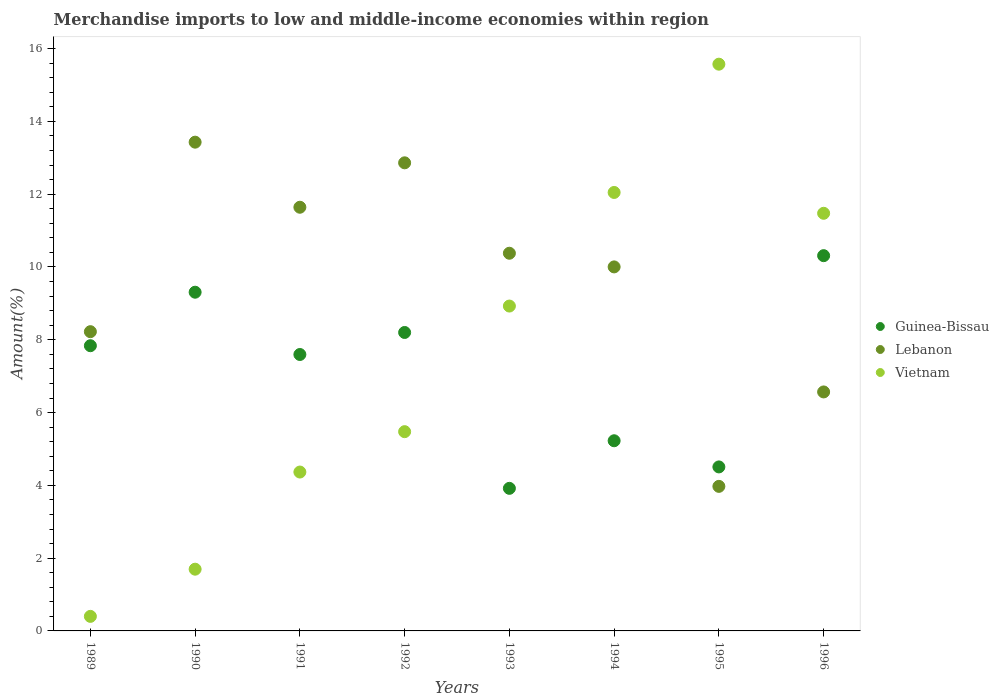Is the number of dotlines equal to the number of legend labels?
Your answer should be very brief. Yes. What is the percentage of amount earned from merchandise imports in Lebanon in 1996?
Your response must be concise. 6.57. Across all years, what is the maximum percentage of amount earned from merchandise imports in Vietnam?
Ensure brevity in your answer.  15.57. Across all years, what is the minimum percentage of amount earned from merchandise imports in Vietnam?
Provide a succinct answer. 0.4. In which year was the percentage of amount earned from merchandise imports in Lebanon minimum?
Offer a terse response. 1995. What is the total percentage of amount earned from merchandise imports in Vietnam in the graph?
Your response must be concise. 59.96. What is the difference between the percentage of amount earned from merchandise imports in Lebanon in 1989 and that in 1991?
Make the answer very short. -3.42. What is the difference between the percentage of amount earned from merchandise imports in Vietnam in 1994 and the percentage of amount earned from merchandise imports in Guinea-Bissau in 1995?
Make the answer very short. 7.54. What is the average percentage of amount earned from merchandise imports in Vietnam per year?
Make the answer very short. 7.49. In the year 1990, what is the difference between the percentage of amount earned from merchandise imports in Lebanon and percentage of amount earned from merchandise imports in Guinea-Bissau?
Ensure brevity in your answer.  4.12. In how many years, is the percentage of amount earned from merchandise imports in Guinea-Bissau greater than 4 %?
Give a very brief answer. 7. What is the ratio of the percentage of amount earned from merchandise imports in Lebanon in 1991 to that in 1996?
Your response must be concise. 1.77. Is the percentage of amount earned from merchandise imports in Guinea-Bissau in 1993 less than that in 1996?
Keep it short and to the point. Yes. What is the difference between the highest and the second highest percentage of amount earned from merchandise imports in Guinea-Bissau?
Provide a short and direct response. 1. What is the difference between the highest and the lowest percentage of amount earned from merchandise imports in Vietnam?
Ensure brevity in your answer.  15.17. In how many years, is the percentage of amount earned from merchandise imports in Vietnam greater than the average percentage of amount earned from merchandise imports in Vietnam taken over all years?
Ensure brevity in your answer.  4. Is the sum of the percentage of amount earned from merchandise imports in Vietnam in 1991 and 1996 greater than the maximum percentage of amount earned from merchandise imports in Lebanon across all years?
Keep it short and to the point. Yes. Is it the case that in every year, the sum of the percentage of amount earned from merchandise imports in Guinea-Bissau and percentage of amount earned from merchandise imports in Vietnam  is greater than the percentage of amount earned from merchandise imports in Lebanon?
Provide a short and direct response. No. Is the percentage of amount earned from merchandise imports in Guinea-Bissau strictly greater than the percentage of amount earned from merchandise imports in Lebanon over the years?
Your response must be concise. No. Is the percentage of amount earned from merchandise imports in Guinea-Bissau strictly less than the percentage of amount earned from merchandise imports in Vietnam over the years?
Provide a succinct answer. No. How many years are there in the graph?
Provide a succinct answer. 8. What is the difference between two consecutive major ticks on the Y-axis?
Offer a terse response. 2. Are the values on the major ticks of Y-axis written in scientific E-notation?
Your answer should be compact. No. Does the graph contain any zero values?
Offer a very short reply. No. How many legend labels are there?
Provide a short and direct response. 3. What is the title of the graph?
Offer a very short reply. Merchandise imports to low and middle-income economies within region. What is the label or title of the Y-axis?
Keep it short and to the point. Amount(%). What is the Amount(%) in Guinea-Bissau in 1989?
Provide a succinct answer. 7.84. What is the Amount(%) in Lebanon in 1989?
Your response must be concise. 8.22. What is the Amount(%) in Vietnam in 1989?
Make the answer very short. 0.4. What is the Amount(%) of Guinea-Bissau in 1990?
Make the answer very short. 9.31. What is the Amount(%) in Lebanon in 1990?
Make the answer very short. 13.43. What is the Amount(%) in Vietnam in 1990?
Make the answer very short. 1.7. What is the Amount(%) in Guinea-Bissau in 1991?
Provide a succinct answer. 7.6. What is the Amount(%) of Lebanon in 1991?
Provide a short and direct response. 11.64. What is the Amount(%) of Vietnam in 1991?
Keep it short and to the point. 4.37. What is the Amount(%) of Guinea-Bissau in 1992?
Provide a short and direct response. 8.2. What is the Amount(%) in Lebanon in 1992?
Offer a terse response. 12.86. What is the Amount(%) in Vietnam in 1992?
Provide a short and direct response. 5.48. What is the Amount(%) of Guinea-Bissau in 1993?
Ensure brevity in your answer.  3.92. What is the Amount(%) in Lebanon in 1993?
Keep it short and to the point. 10.38. What is the Amount(%) of Vietnam in 1993?
Your answer should be very brief. 8.93. What is the Amount(%) in Guinea-Bissau in 1994?
Keep it short and to the point. 5.23. What is the Amount(%) of Lebanon in 1994?
Offer a very short reply. 10. What is the Amount(%) of Vietnam in 1994?
Your response must be concise. 12.05. What is the Amount(%) of Guinea-Bissau in 1995?
Keep it short and to the point. 4.51. What is the Amount(%) of Lebanon in 1995?
Ensure brevity in your answer.  3.97. What is the Amount(%) in Vietnam in 1995?
Your answer should be compact. 15.57. What is the Amount(%) of Guinea-Bissau in 1996?
Offer a terse response. 10.31. What is the Amount(%) of Lebanon in 1996?
Your answer should be very brief. 6.57. What is the Amount(%) in Vietnam in 1996?
Provide a succinct answer. 11.48. Across all years, what is the maximum Amount(%) in Guinea-Bissau?
Make the answer very short. 10.31. Across all years, what is the maximum Amount(%) in Lebanon?
Give a very brief answer. 13.43. Across all years, what is the maximum Amount(%) of Vietnam?
Make the answer very short. 15.57. Across all years, what is the minimum Amount(%) of Guinea-Bissau?
Offer a terse response. 3.92. Across all years, what is the minimum Amount(%) in Lebanon?
Provide a short and direct response. 3.97. Across all years, what is the minimum Amount(%) of Vietnam?
Your answer should be very brief. 0.4. What is the total Amount(%) of Guinea-Bissau in the graph?
Provide a succinct answer. 56.9. What is the total Amount(%) in Lebanon in the graph?
Your answer should be very brief. 77.07. What is the total Amount(%) in Vietnam in the graph?
Ensure brevity in your answer.  59.96. What is the difference between the Amount(%) in Guinea-Bissau in 1989 and that in 1990?
Give a very brief answer. -1.47. What is the difference between the Amount(%) in Lebanon in 1989 and that in 1990?
Keep it short and to the point. -5.21. What is the difference between the Amount(%) in Vietnam in 1989 and that in 1990?
Make the answer very short. -1.3. What is the difference between the Amount(%) of Guinea-Bissau in 1989 and that in 1991?
Offer a very short reply. 0.24. What is the difference between the Amount(%) of Lebanon in 1989 and that in 1991?
Your response must be concise. -3.42. What is the difference between the Amount(%) of Vietnam in 1989 and that in 1991?
Provide a short and direct response. -3.97. What is the difference between the Amount(%) of Guinea-Bissau in 1989 and that in 1992?
Make the answer very short. -0.36. What is the difference between the Amount(%) in Lebanon in 1989 and that in 1992?
Your answer should be very brief. -4.64. What is the difference between the Amount(%) of Vietnam in 1989 and that in 1992?
Keep it short and to the point. -5.08. What is the difference between the Amount(%) of Guinea-Bissau in 1989 and that in 1993?
Provide a succinct answer. 3.92. What is the difference between the Amount(%) of Lebanon in 1989 and that in 1993?
Your answer should be compact. -2.16. What is the difference between the Amount(%) in Vietnam in 1989 and that in 1993?
Your response must be concise. -8.53. What is the difference between the Amount(%) in Guinea-Bissau in 1989 and that in 1994?
Your answer should be compact. 2.61. What is the difference between the Amount(%) in Lebanon in 1989 and that in 1994?
Your response must be concise. -1.78. What is the difference between the Amount(%) of Vietnam in 1989 and that in 1994?
Keep it short and to the point. -11.65. What is the difference between the Amount(%) of Guinea-Bissau in 1989 and that in 1995?
Ensure brevity in your answer.  3.33. What is the difference between the Amount(%) of Lebanon in 1989 and that in 1995?
Provide a short and direct response. 4.25. What is the difference between the Amount(%) in Vietnam in 1989 and that in 1995?
Make the answer very short. -15.17. What is the difference between the Amount(%) of Guinea-Bissau in 1989 and that in 1996?
Make the answer very short. -2.47. What is the difference between the Amount(%) of Lebanon in 1989 and that in 1996?
Your answer should be compact. 1.66. What is the difference between the Amount(%) in Vietnam in 1989 and that in 1996?
Make the answer very short. -11.08. What is the difference between the Amount(%) in Guinea-Bissau in 1990 and that in 1991?
Ensure brevity in your answer.  1.71. What is the difference between the Amount(%) in Lebanon in 1990 and that in 1991?
Provide a short and direct response. 1.79. What is the difference between the Amount(%) in Vietnam in 1990 and that in 1991?
Offer a terse response. -2.67. What is the difference between the Amount(%) in Guinea-Bissau in 1990 and that in 1992?
Offer a very short reply. 1.11. What is the difference between the Amount(%) in Lebanon in 1990 and that in 1992?
Offer a terse response. 0.57. What is the difference between the Amount(%) of Vietnam in 1990 and that in 1992?
Keep it short and to the point. -3.78. What is the difference between the Amount(%) of Guinea-Bissau in 1990 and that in 1993?
Provide a succinct answer. 5.39. What is the difference between the Amount(%) of Lebanon in 1990 and that in 1993?
Ensure brevity in your answer.  3.05. What is the difference between the Amount(%) in Vietnam in 1990 and that in 1993?
Keep it short and to the point. -7.23. What is the difference between the Amount(%) in Guinea-Bissau in 1990 and that in 1994?
Offer a terse response. 4.08. What is the difference between the Amount(%) of Lebanon in 1990 and that in 1994?
Provide a succinct answer. 3.43. What is the difference between the Amount(%) of Vietnam in 1990 and that in 1994?
Provide a succinct answer. -10.35. What is the difference between the Amount(%) in Guinea-Bissau in 1990 and that in 1995?
Your answer should be compact. 4.8. What is the difference between the Amount(%) in Lebanon in 1990 and that in 1995?
Your answer should be compact. 9.46. What is the difference between the Amount(%) in Vietnam in 1990 and that in 1995?
Provide a succinct answer. -13.88. What is the difference between the Amount(%) in Guinea-Bissau in 1990 and that in 1996?
Your answer should be compact. -1. What is the difference between the Amount(%) of Lebanon in 1990 and that in 1996?
Give a very brief answer. 6.86. What is the difference between the Amount(%) of Vietnam in 1990 and that in 1996?
Provide a short and direct response. -9.78. What is the difference between the Amount(%) of Guinea-Bissau in 1991 and that in 1992?
Your response must be concise. -0.61. What is the difference between the Amount(%) of Lebanon in 1991 and that in 1992?
Offer a very short reply. -1.22. What is the difference between the Amount(%) in Vietnam in 1991 and that in 1992?
Provide a succinct answer. -1.11. What is the difference between the Amount(%) in Guinea-Bissau in 1991 and that in 1993?
Your answer should be compact. 3.68. What is the difference between the Amount(%) in Lebanon in 1991 and that in 1993?
Offer a very short reply. 1.26. What is the difference between the Amount(%) in Vietnam in 1991 and that in 1993?
Provide a short and direct response. -4.56. What is the difference between the Amount(%) of Guinea-Bissau in 1991 and that in 1994?
Provide a short and direct response. 2.37. What is the difference between the Amount(%) of Lebanon in 1991 and that in 1994?
Keep it short and to the point. 1.64. What is the difference between the Amount(%) of Vietnam in 1991 and that in 1994?
Provide a short and direct response. -7.68. What is the difference between the Amount(%) in Guinea-Bissau in 1991 and that in 1995?
Offer a very short reply. 3.09. What is the difference between the Amount(%) of Lebanon in 1991 and that in 1995?
Provide a succinct answer. 7.67. What is the difference between the Amount(%) of Vietnam in 1991 and that in 1995?
Provide a succinct answer. -11.21. What is the difference between the Amount(%) of Guinea-Bissau in 1991 and that in 1996?
Give a very brief answer. -2.72. What is the difference between the Amount(%) in Lebanon in 1991 and that in 1996?
Give a very brief answer. 5.07. What is the difference between the Amount(%) in Vietnam in 1991 and that in 1996?
Provide a short and direct response. -7.11. What is the difference between the Amount(%) in Guinea-Bissau in 1992 and that in 1993?
Your answer should be compact. 4.28. What is the difference between the Amount(%) of Lebanon in 1992 and that in 1993?
Your answer should be compact. 2.48. What is the difference between the Amount(%) of Vietnam in 1992 and that in 1993?
Offer a very short reply. -3.45. What is the difference between the Amount(%) of Guinea-Bissau in 1992 and that in 1994?
Give a very brief answer. 2.98. What is the difference between the Amount(%) of Lebanon in 1992 and that in 1994?
Offer a terse response. 2.86. What is the difference between the Amount(%) in Vietnam in 1992 and that in 1994?
Ensure brevity in your answer.  -6.57. What is the difference between the Amount(%) of Guinea-Bissau in 1992 and that in 1995?
Make the answer very short. 3.69. What is the difference between the Amount(%) of Lebanon in 1992 and that in 1995?
Your answer should be very brief. 8.89. What is the difference between the Amount(%) of Vietnam in 1992 and that in 1995?
Give a very brief answer. -10.1. What is the difference between the Amount(%) in Guinea-Bissau in 1992 and that in 1996?
Offer a terse response. -2.11. What is the difference between the Amount(%) of Lebanon in 1992 and that in 1996?
Give a very brief answer. 6.3. What is the difference between the Amount(%) in Vietnam in 1992 and that in 1996?
Your answer should be very brief. -6. What is the difference between the Amount(%) in Guinea-Bissau in 1993 and that in 1994?
Your response must be concise. -1.31. What is the difference between the Amount(%) in Lebanon in 1993 and that in 1994?
Offer a very short reply. 0.38. What is the difference between the Amount(%) of Vietnam in 1993 and that in 1994?
Your answer should be very brief. -3.12. What is the difference between the Amount(%) in Guinea-Bissau in 1993 and that in 1995?
Give a very brief answer. -0.59. What is the difference between the Amount(%) of Lebanon in 1993 and that in 1995?
Provide a short and direct response. 6.41. What is the difference between the Amount(%) of Vietnam in 1993 and that in 1995?
Provide a short and direct response. -6.65. What is the difference between the Amount(%) in Guinea-Bissau in 1993 and that in 1996?
Provide a succinct answer. -6.39. What is the difference between the Amount(%) of Lebanon in 1993 and that in 1996?
Give a very brief answer. 3.81. What is the difference between the Amount(%) of Vietnam in 1993 and that in 1996?
Make the answer very short. -2.55. What is the difference between the Amount(%) in Guinea-Bissau in 1994 and that in 1995?
Keep it short and to the point. 0.72. What is the difference between the Amount(%) in Lebanon in 1994 and that in 1995?
Provide a succinct answer. 6.03. What is the difference between the Amount(%) of Vietnam in 1994 and that in 1995?
Your response must be concise. -3.52. What is the difference between the Amount(%) of Guinea-Bissau in 1994 and that in 1996?
Your answer should be very brief. -5.09. What is the difference between the Amount(%) of Lebanon in 1994 and that in 1996?
Your answer should be very brief. 3.44. What is the difference between the Amount(%) of Vietnam in 1994 and that in 1996?
Give a very brief answer. 0.57. What is the difference between the Amount(%) in Guinea-Bissau in 1995 and that in 1996?
Offer a very short reply. -5.8. What is the difference between the Amount(%) in Lebanon in 1995 and that in 1996?
Your response must be concise. -2.59. What is the difference between the Amount(%) of Vietnam in 1995 and that in 1996?
Your response must be concise. 4.1. What is the difference between the Amount(%) of Guinea-Bissau in 1989 and the Amount(%) of Lebanon in 1990?
Your response must be concise. -5.59. What is the difference between the Amount(%) of Guinea-Bissau in 1989 and the Amount(%) of Vietnam in 1990?
Your response must be concise. 6.14. What is the difference between the Amount(%) of Lebanon in 1989 and the Amount(%) of Vietnam in 1990?
Offer a very short reply. 6.53. What is the difference between the Amount(%) in Guinea-Bissau in 1989 and the Amount(%) in Lebanon in 1991?
Offer a very short reply. -3.8. What is the difference between the Amount(%) in Guinea-Bissau in 1989 and the Amount(%) in Vietnam in 1991?
Provide a succinct answer. 3.47. What is the difference between the Amount(%) of Lebanon in 1989 and the Amount(%) of Vietnam in 1991?
Your response must be concise. 3.86. What is the difference between the Amount(%) of Guinea-Bissau in 1989 and the Amount(%) of Lebanon in 1992?
Give a very brief answer. -5.03. What is the difference between the Amount(%) in Guinea-Bissau in 1989 and the Amount(%) in Vietnam in 1992?
Give a very brief answer. 2.36. What is the difference between the Amount(%) in Lebanon in 1989 and the Amount(%) in Vietnam in 1992?
Make the answer very short. 2.75. What is the difference between the Amount(%) of Guinea-Bissau in 1989 and the Amount(%) of Lebanon in 1993?
Offer a very short reply. -2.54. What is the difference between the Amount(%) of Guinea-Bissau in 1989 and the Amount(%) of Vietnam in 1993?
Keep it short and to the point. -1.09. What is the difference between the Amount(%) of Lebanon in 1989 and the Amount(%) of Vietnam in 1993?
Make the answer very short. -0.7. What is the difference between the Amount(%) of Guinea-Bissau in 1989 and the Amount(%) of Lebanon in 1994?
Your response must be concise. -2.17. What is the difference between the Amount(%) of Guinea-Bissau in 1989 and the Amount(%) of Vietnam in 1994?
Provide a short and direct response. -4.21. What is the difference between the Amount(%) of Lebanon in 1989 and the Amount(%) of Vietnam in 1994?
Make the answer very short. -3.83. What is the difference between the Amount(%) of Guinea-Bissau in 1989 and the Amount(%) of Lebanon in 1995?
Provide a short and direct response. 3.86. What is the difference between the Amount(%) in Guinea-Bissau in 1989 and the Amount(%) in Vietnam in 1995?
Provide a short and direct response. -7.74. What is the difference between the Amount(%) of Lebanon in 1989 and the Amount(%) of Vietnam in 1995?
Keep it short and to the point. -7.35. What is the difference between the Amount(%) in Guinea-Bissau in 1989 and the Amount(%) in Lebanon in 1996?
Provide a short and direct response. 1.27. What is the difference between the Amount(%) in Guinea-Bissau in 1989 and the Amount(%) in Vietnam in 1996?
Ensure brevity in your answer.  -3.64. What is the difference between the Amount(%) of Lebanon in 1989 and the Amount(%) of Vietnam in 1996?
Offer a very short reply. -3.25. What is the difference between the Amount(%) in Guinea-Bissau in 1990 and the Amount(%) in Lebanon in 1991?
Your answer should be compact. -2.33. What is the difference between the Amount(%) of Guinea-Bissau in 1990 and the Amount(%) of Vietnam in 1991?
Give a very brief answer. 4.94. What is the difference between the Amount(%) in Lebanon in 1990 and the Amount(%) in Vietnam in 1991?
Your answer should be very brief. 9.06. What is the difference between the Amount(%) in Guinea-Bissau in 1990 and the Amount(%) in Lebanon in 1992?
Give a very brief answer. -3.56. What is the difference between the Amount(%) of Guinea-Bissau in 1990 and the Amount(%) of Vietnam in 1992?
Provide a succinct answer. 3.83. What is the difference between the Amount(%) of Lebanon in 1990 and the Amount(%) of Vietnam in 1992?
Provide a succinct answer. 7.95. What is the difference between the Amount(%) in Guinea-Bissau in 1990 and the Amount(%) in Lebanon in 1993?
Ensure brevity in your answer.  -1.07. What is the difference between the Amount(%) in Guinea-Bissau in 1990 and the Amount(%) in Vietnam in 1993?
Make the answer very short. 0.38. What is the difference between the Amount(%) in Lebanon in 1990 and the Amount(%) in Vietnam in 1993?
Offer a terse response. 4.5. What is the difference between the Amount(%) in Guinea-Bissau in 1990 and the Amount(%) in Lebanon in 1994?
Keep it short and to the point. -0.7. What is the difference between the Amount(%) in Guinea-Bissau in 1990 and the Amount(%) in Vietnam in 1994?
Offer a terse response. -2.74. What is the difference between the Amount(%) of Lebanon in 1990 and the Amount(%) of Vietnam in 1994?
Your answer should be very brief. 1.38. What is the difference between the Amount(%) in Guinea-Bissau in 1990 and the Amount(%) in Lebanon in 1995?
Your answer should be very brief. 5.33. What is the difference between the Amount(%) of Guinea-Bissau in 1990 and the Amount(%) of Vietnam in 1995?
Your response must be concise. -6.27. What is the difference between the Amount(%) in Lebanon in 1990 and the Amount(%) in Vietnam in 1995?
Give a very brief answer. -2.14. What is the difference between the Amount(%) of Guinea-Bissau in 1990 and the Amount(%) of Lebanon in 1996?
Provide a short and direct response. 2.74. What is the difference between the Amount(%) of Guinea-Bissau in 1990 and the Amount(%) of Vietnam in 1996?
Offer a very short reply. -2.17. What is the difference between the Amount(%) of Lebanon in 1990 and the Amount(%) of Vietnam in 1996?
Your answer should be compact. 1.95. What is the difference between the Amount(%) in Guinea-Bissau in 1991 and the Amount(%) in Lebanon in 1992?
Provide a short and direct response. -5.27. What is the difference between the Amount(%) in Guinea-Bissau in 1991 and the Amount(%) in Vietnam in 1992?
Offer a terse response. 2.12. What is the difference between the Amount(%) of Lebanon in 1991 and the Amount(%) of Vietnam in 1992?
Offer a very short reply. 6.17. What is the difference between the Amount(%) of Guinea-Bissau in 1991 and the Amount(%) of Lebanon in 1993?
Provide a short and direct response. -2.78. What is the difference between the Amount(%) of Guinea-Bissau in 1991 and the Amount(%) of Vietnam in 1993?
Provide a succinct answer. -1.33. What is the difference between the Amount(%) in Lebanon in 1991 and the Amount(%) in Vietnam in 1993?
Make the answer very short. 2.71. What is the difference between the Amount(%) in Guinea-Bissau in 1991 and the Amount(%) in Lebanon in 1994?
Offer a terse response. -2.41. What is the difference between the Amount(%) in Guinea-Bissau in 1991 and the Amount(%) in Vietnam in 1994?
Your answer should be very brief. -4.45. What is the difference between the Amount(%) in Lebanon in 1991 and the Amount(%) in Vietnam in 1994?
Ensure brevity in your answer.  -0.41. What is the difference between the Amount(%) in Guinea-Bissau in 1991 and the Amount(%) in Lebanon in 1995?
Give a very brief answer. 3.62. What is the difference between the Amount(%) in Guinea-Bissau in 1991 and the Amount(%) in Vietnam in 1995?
Give a very brief answer. -7.98. What is the difference between the Amount(%) of Lebanon in 1991 and the Amount(%) of Vietnam in 1995?
Your response must be concise. -3.93. What is the difference between the Amount(%) in Guinea-Bissau in 1991 and the Amount(%) in Lebanon in 1996?
Offer a very short reply. 1.03. What is the difference between the Amount(%) of Guinea-Bissau in 1991 and the Amount(%) of Vietnam in 1996?
Provide a succinct answer. -3.88. What is the difference between the Amount(%) of Lebanon in 1991 and the Amount(%) of Vietnam in 1996?
Your response must be concise. 0.17. What is the difference between the Amount(%) of Guinea-Bissau in 1992 and the Amount(%) of Lebanon in 1993?
Keep it short and to the point. -2.18. What is the difference between the Amount(%) in Guinea-Bissau in 1992 and the Amount(%) in Vietnam in 1993?
Your answer should be very brief. -0.73. What is the difference between the Amount(%) of Lebanon in 1992 and the Amount(%) of Vietnam in 1993?
Ensure brevity in your answer.  3.94. What is the difference between the Amount(%) of Guinea-Bissau in 1992 and the Amount(%) of Lebanon in 1994?
Your answer should be very brief. -1.8. What is the difference between the Amount(%) in Guinea-Bissau in 1992 and the Amount(%) in Vietnam in 1994?
Offer a very short reply. -3.85. What is the difference between the Amount(%) in Lebanon in 1992 and the Amount(%) in Vietnam in 1994?
Give a very brief answer. 0.81. What is the difference between the Amount(%) of Guinea-Bissau in 1992 and the Amount(%) of Lebanon in 1995?
Make the answer very short. 4.23. What is the difference between the Amount(%) of Guinea-Bissau in 1992 and the Amount(%) of Vietnam in 1995?
Make the answer very short. -7.37. What is the difference between the Amount(%) of Lebanon in 1992 and the Amount(%) of Vietnam in 1995?
Offer a very short reply. -2.71. What is the difference between the Amount(%) of Guinea-Bissau in 1992 and the Amount(%) of Lebanon in 1996?
Provide a short and direct response. 1.63. What is the difference between the Amount(%) in Guinea-Bissau in 1992 and the Amount(%) in Vietnam in 1996?
Offer a terse response. -3.27. What is the difference between the Amount(%) of Lebanon in 1992 and the Amount(%) of Vietnam in 1996?
Ensure brevity in your answer.  1.39. What is the difference between the Amount(%) in Guinea-Bissau in 1993 and the Amount(%) in Lebanon in 1994?
Your answer should be very brief. -6.08. What is the difference between the Amount(%) of Guinea-Bissau in 1993 and the Amount(%) of Vietnam in 1994?
Give a very brief answer. -8.13. What is the difference between the Amount(%) in Lebanon in 1993 and the Amount(%) in Vietnam in 1994?
Your answer should be very brief. -1.67. What is the difference between the Amount(%) of Guinea-Bissau in 1993 and the Amount(%) of Lebanon in 1995?
Your answer should be compact. -0.05. What is the difference between the Amount(%) of Guinea-Bissau in 1993 and the Amount(%) of Vietnam in 1995?
Your answer should be very brief. -11.65. What is the difference between the Amount(%) in Lebanon in 1993 and the Amount(%) in Vietnam in 1995?
Your response must be concise. -5.2. What is the difference between the Amount(%) of Guinea-Bissau in 1993 and the Amount(%) of Lebanon in 1996?
Your answer should be compact. -2.65. What is the difference between the Amount(%) in Guinea-Bissau in 1993 and the Amount(%) in Vietnam in 1996?
Give a very brief answer. -7.56. What is the difference between the Amount(%) of Lebanon in 1993 and the Amount(%) of Vietnam in 1996?
Ensure brevity in your answer.  -1.1. What is the difference between the Amount(%) in Guinea-Bissau in 1994 and the Amount(%) in Lebanon in 1995?
Give a very brief answer. 1.25. What is the difference between the Amount(%) of Guinea-Bissau in 1994 and the Amount(%) of Vietnam in 1995?
Your answer should be very brief. -10.35. What is the difference between the Amount(%) in Lebanon in 1994 and the Amount(%) in Vietnam in 1995?
Keep it short and to the point. -5.57. What is the difference between the Amount(%) of Guinea-Bissau in 1994 and the Amount(%) of Lebanon in 1996?
Your response must be concise. -1.34. What is the difference between the Amount(%) of Guinea-Bissau in 1994 and the Amount(%) of Vietnam in 1996?
Your answer should be very brief. -6.25. What is the difference between the Amount(%) in Lebanon in 1994 and the Amount(%) in Vietnam in 1996?
Offer a very short reply. -1.47. What is the difference between the Amount(%) in Guinea-Bissau in 1995 and the Amount(%) in Lebanon in 1996?
Your answer should be compact. -2.06. What is the difference between the Amount(%) of Guinea-Bissau in 1995 and the Amount(%) of Vietnam in 1996?
Ensure brevity in your answer.  -6.97. What is the difference between the Amount(%) of Lebanon in 1995 and the Amount(%) of Vietnam in 1996?
Your response must be concise. -7.5. What is the average Amount(%) in Guinea-Bissau per year?
Provide a short and direct response. 7.11. What is the average Amount(%) in Lebanon per year?
Offer a very short reply. 9.63. What is the average Amount(%) in Vietnam per year?
Make the answer very short. 7.49. In the year 1989, what is the difference between the Amount(%) of Guinea-Bissau and Amount(%) of Lebanon?
Provide a succinct answer. -0.39. In the year 1989, what is the difference between the Amount(%) in Guinea-Bissau and Amount(%) in Vietnam?
Your answer should be compact. 7.44. In the year 1989, what is the difference between the Amount(%) of Lebanon and Amount(%) of Vietnam?
Ensure brevity in your answer.  7.82. In the year 1990, what is the difference between the Amount(%) of Guinea-Bissau and Amount(%) of Lebanon?
Your answer should be very brief. -4.12. In the year 1990, what is the difference between the Amount(%) of Guinea-Bissau and Amount(%) of Vietnam?
Ensure brevity in your answer.  7.61. In the year 1990, what is the difference between the Amount(%) in Lebanon and Amount(%) in Vietnam?
Provide a short and direct response. 11.73. In the year 1991, what is the difference between the Amount(%) in Guinea-Bissau and Amount(%) in Lebanon?
Your answer should be very brief. -4.05. In the year 1991, what is the difference between the Amount(%) in Guinea-Bissau and Amount(%) in Vietnam?
Your answer should be compact. 3.23. In the year 1991, what is the difference between the Amount(%) in Lebanon and Amount(%) in Vietnam?
Make the answer very short. 7.28. In the year 1992, what is the difference between the Amount(%) of Guinea-Bissau and Amount(%) of Lebanon?
Offer a very short reply. -4.66. In the year 1992, what is the difference between the Amount(%) of Guinea-Bissau and Amount(%) of Vietnam?
Your answer should be very brief. 2.73. In the year 1992, what is the difference between the Amount(%) of Lebanon and Amount(%) of Vietnam?
Provide a succinct answer. 7.39. In the year 1993, what is the difference between the Amount(%) of Guinea-Bissau and Amount(%) of Lebanon?
Your answer should be compact. -6.46. In the year 1993, what is the difference between the Amount(%) of Guinea-Bissau and Amount(%) of Vietnam?
Ensure brevity in your answer.  -5.01. In the year 1993, what is the difference between the Amount(%) of Lebanon and Amount(%) of Vietnam?
Your response must be concise. 1.45. In the year 1994, what is the difference between the Amount(%) in Guinea-Bissau and Amount(%) in Lebanon?
Your response must be concise. -4.78. In the year 1994, what is the difference between the Amount(%) of Guinea-Bissau and Amount(%) of Vietnam?
Provide a succinct answer. -6.82. In the year 1994, what is the difference between the Amount(%) of Lebanon and Amount(%) of Vietnam?
Your answer should be compact. -2.05. In the year 1995, what is the difference between the Amount(%) of Guinea-Bissau and Amount(%) of Lebanon?
Ensure brevity in your answer.  0.53. In the year 1995, what is the difference between the Amount(%) of Guinea-Bissau and Amount(%) of Vietnam?
Provide a short and direct response. -11.07. In the year 1995, what is the difference between the Amount(%) in Lebanon and Amount(%) in Vietnam?
Offer a terse response. -11.6. In the year 1996, what is the difference between the Amount(%) in Guinea-Bissau and Amount(%) in Lebanon?
Your response must be concise. 3.74. In the year 1996, what is the difference between the Amount(%) in Guinea-Bissau and Amount(%) in Vietnam?
Your response must be concise. -1.16. In the year 1996, what is the difference between the Amount(%) in Lebanon and Amount(%) in Vietnam?
Give a very brief answer. -4.91. What is the ratio of the Amount(%) of Guinea-Bissau in 1989 to that in 1990?
Make the answer very short. 0.84. What is the ratio of the Amount(%) in Lebanon in 1989 to that in 1990?
Your response must be concise. 0.61. What is the ratio of the Amount(%) of Vietnam in 1989 to that in 1990?
Ensure brevity in your answer.  0.24. What is the ratio of the Amount(%) in Guinea-Bissau in 1989 to that in 1991?
Your answer should be compact. 1.03. What is the ratio of the Amount(%) in Lebanon in 1989 to that in 1991?
Provide a short and direct response. 0.71. What is the ratio of the Amount(%) of Vietnam in 1989 to that in 1991?
Give a very brief answer. 0.09. What is the ratio of the Amount(%) of Guinea-Bissau in 1989 to that in 1992?
Make the answer very short. 0.96. What is the ratio of the Amount(%) in Lebanon in 1989 to that in 1992?
Your answer should be very brief. 0.64. What is the ratio of the Amount(%) of Vietnam in 1989 to that in 1992?
Keep it short and to the point. 0.07. What is the ratio of the Amount(%) of Guinea-Bissau in 1989 to that in 1993?
Provide a succinct answer. 2. What is the ratio of the Amount(%) of Lebanon in 1989 to that in 1993?
Offer a very short reply. 0.79. What is the ratio of the Amount(%) of Vietnam in 1989 to that in 1993?
Ensure brevity in your answer.  0.04. What is the ratio of the Amount(%) of Guinea-Bissau in 1989 to that in 1994?
Your response must be concise. 1.5. What is the ratio of the Amount(%) in Lebanon in 1989 to that in 1994?
Offer a very short reply. 0.82. What is the ratio of the Amount(%) in Vietnam in 1989 to that in 1994?
Give a very brief answer. 0.03. What is the ratio of the Amount(%) of Guinea-Bissau in 1989 to that in 1995?
Offer a very short reply. 1.74. What is the ratio of the Amount(%) of Lebanon in 1989 to that in 1995?
Make the answer very short. 2.07. What is the ratio of the Amount(%) of Vietnam in 1989 to that in 1995?
Keep it short and to the point. 0.03. What is the ratio of the Amount(%) of Guinea-Bissau in 1989 to that in 1996?
Keep it short and to the point. 0.76. What is the ratio of the Amount(%) of Lebanon in 1989 to that in 1996?
Your answer should be compact. 1.25. What is the ratio of the Amount(%) of Vietnam in 1989 to that in 1996?
Provide a succinct answer. 0.03. What is the ratio of the Amount(%) of Guinea-Bissau in 1990 to that in 1991?
Your answer should be compact. 1.23. What is the ratio of the Amount(%) of Lebanon in 1990 to that in 1991?
Give a very brief answer. 1.15. What is the ratio of the Amount(%) in Vietnam in 1990 to that in 1991?
Make the answer very short. 0.39. What is the ratio of the Amount(%) of Guinea-Bissau in 1990 to that in 1992?
Give a very brief answer. 1.13. What is the ratio of the Amount(%) in Lebanon in 1990 to that in 1992?
Your response must be concise. 1.04. What is the ratio of the Amount(%) in Vietnam in 1990 to that in 1992?
Offer a terse response. 0.31. What is the ratio of the Amount(%) of Guinea-Bissau in 1990 to that in 1993?
Offer a very short reply. 2.38. What is the ratio of the Amount(%) of Lebanon in 1990 to that in 1993?
Make the answer very short. 1.29. What is the ratio of the Amount(%) of Vietnam in 1990 to that in 1993?
Provide a short and direct response. 0.19. What is the ratio of the Amount(%) of Guinea-Bissau in 1990 to that in 1994?
Keep it short and to the point. 1.78. What is the ratio of the Amount(%) in Lebanon in 1990 to that in 1994?
Make the answer very short. 1.34. What is the ratio of the Amount(%) of Vietnam in 1990 to that in 1994?
Provide a succinct answer. 0.14. What is the ratio of the Amount(%) in Guinea-Bissau in 1990 to that in 1995?
Offer a very short reply. 2.07. What is the ratio of the Amount(%) in Lebanon in 1990 to that in 1995?
Offer a terse response. 3.38. What is the ratio of the Amount(%) in Vietnam in 1990 to that in 1995?
Ensure brevity in your answer.  0.11. What is the ratio of the Amount(%) in Guinea-Bissau in 1990 to that in 1996?
Ensure brevity in your answer.  0.9. What is the ratio of the Amount(%) in Lebanon in 1990 to that in 1996?
Your answer should be very brief. 2.05. What is the ratio of the Amount(%) of Vietnam in 1990 to that in 1996?
Offer a terse response. 0.15. What is the ratio of the Amount(%) of Guinea-Bissau in 1991 to that in 1992?
Keep it short and to the point. 0.93. What is the ratio of the Amount(%) in Lebanon in 1991 to that in 1992?
Give a very brief answer. 0.91. What is the ratio of the Amount(%) of Vietnam in 1991 to that in 1992?
Keep it short and to the point. 0.8. What is the ratio of the Amount(%) in Guinea-Bissau in 1991 to that in 1993?
Your answer should be compact. 1.94. What is the ratio of the Amount(%) of Lebanon in 1991 to that in 1993?
Your answer should be very brief. 1.12. What is the ratio of the Amount(%) in Vietnam in 1991 to that in 1993?
Your answer should be compact. 0.49. What is the ratio of the Amount(%) in Guinea-Bissau in 1991 to that in 1994?
Ensure brevity in your answer.  1.45. What is the ratio of the Amount(%) in Lebanon in 1991 to that in 1994?
Keep it short and to the point. 1.16. What is the ratio of the Amount(%) of Vietnam in 1991 to that in 1994?
Give a very brief answer. 0.36. What is the ratio of the Amount(%) of Guinea-Bissau in 1991 to that in 1995?
Keep it short and to the point. 1.69. What is the ratio of the Amount(%) in Lebanon in 1991 to that in 1995?
Provide a succinct answer. 2.93. What is the ratio of the Amount(%) in Vietnam in 1991 to that in 1995?
Offer a terse response. 0.28. What is the ratio of the Amount(%) of Guinea-Bissau in 1991 to that in 1996?
Offer a very short reply. 0.74. What is the ratio of the Amount(%) in Lebanon in 1991 to that in 1996?
Ensure brevity in your answer.  1.77. What is the ratio of the Amount(%) in Vietnam in 1991 to that in 1996?
Provide a short and direct response. 0.38. What is the ratio of the Amount(%) in Guinea-Bissau in 1992 to that in 1993?
Make the answer very short. 2.09. What is the ratio of the Amount(%) of Lebanon in 1992 to that in 1993?
Ensure brevity in your answer.  1.24. What is the ratio of the Amount(%) in Vietnam in 1992 to that in 1993?
Provide a short and direct response. 0.61. What is the ratio of the Amount(%) in Guinea-Bissau in 1992 to that in 1994?
Offer a very short reply. 1.57. What is the ratio of the Amount(%) in Lebanon in 1992 to that in 1994?
Your answer should be very brief. 1.29. What is the ratio of the Amount(%) of Vietnam in 1992 to that in 1994?
Ensure brevity in your answer.  0.45. What is the ratio of the Amount(%) in Guinea-Bissau in 1992 to that in 1995?
Your response must be concise. 1.82. What is the ratio of the Amount(%) of Lebanon in 1992 to that in 1995?
Provide a short and direct response. 3.24. What is the ratio of the Amount(%) of Vietnam in 1992 to that in 1995?
Keep it short and to the point. 0.35. What is the ratio of the Amount(%) of Guinea-Bissau in 1992 to that in 1996?
Ensure brevity in your answer.  0.8. What is the ratio of the Amount(%) of Lebanon in 1992 to that in 1996?
Your answer should be compact. 1.96. What is the ratio of the Amount(%) of Vietnam in 1992 to that in 1996?
Offer a very short reply. 0.48. What is the ratio of the Amount(%) in Guinea-Bissau in 1993 to that in 1994?
Provide a succinct answer. 0.75. What is the ratio of the Amount(%) of Lebanon in 1993 to that in 1994?
Provide a short and direct response. 1.04. What is the ratio of the Amount(%) in Vietnam in 1993 to that in 1994?
Provide a short and direct response. 0.74. What is the ratio of the Amount(%) of Guinea-Bissau in 1993 to that in 1995?
Keep it short and to the point. 0.87. What is the ratio of the Amount(%) of Lebanon in 1993 to that in 1995?
Provide a succinct answer. 2.61. What is the ratio of the Amount(%) of Vietnam in 1993 to that in 1995?
Provide a short and direct response. 0.57. What is the ratio of the Amount(%) in Guinea-Bissau in 1993 to that in 1996?
Provide a short and direct response. 0.38. What is the ratio of the Amount(%) in Lebanon in 1993 to that in 1996?
Offer a terse response. 1.58. What is the ratio of the Amount(%) in Vietnam in 1993 to that in 1996?
Make the answer very short. 0.78. What is the ratio of the Amount(%) in Guinea-Bissau in 1994 to that in 1995?
Keep it short and to the point. 1.16. What is the ratio of the Amount(%) of Lebanon in 1994 to that in 1995?
Make the answer very short. 2.52. What is the ratio of the Amount(%) of Vietnam in 1994 to that in 1995?
Offer a terse response. 0.77. What is the ratio of the Amount(%) of Guinea-Bissau in 1994 to that in 1996?
Provide a succinct answer. 0.51. What is the ratio of the Amount(%) in Lebanon in 1994 to that in 1996?
Your response must be concise. 1.52. What is the ratio of the Amount(%) of Vietnam in 1994 to that in 1996?
Provide a succinct answer. 1.05. What is the ratio of the Amount(%) in Guinea-Bissau in 1995 to that in 1996?
Make the answer very short. 0.44. What is the ratio of the Amount(%) in Lebanon in 1995 to that in 1996?
Offer a very short reply. 0.6. What is the ratio of the Amount(%) in Vietnam in 1995 to that in 1996?
Make the answer very short. 1.36. What is the difference between the highest and the second highest Amount(%) of Lebanon?
Your answer should be very brief. 0.57. What is the difference between the highest and the second highest Amount(%) in Vietnam?
Provide a succinct answer. 3.52. What is the difference between the highest and the lowest Amount(%) of Guinea-Bissau?
Your answer should be compact. 6.39. What is the difference between the highest and the lowest Amount(%) of Lebanon?
Your answer should be compact. 9.46. What is the difference between the highest and the lowest Amount(%) in Vietnam?
Provide a short and direct response. 15.17. 